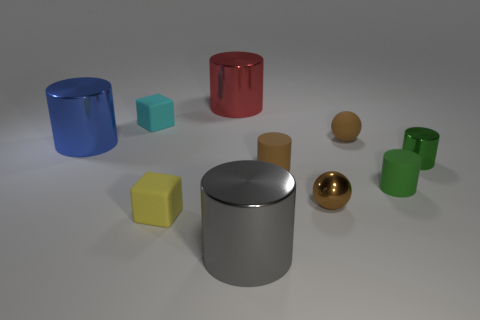Subtract all gray cylinders. How many cylinders are left? 5 Subtract 1 spheres. How many spheres are left? 1 Subtract all blocks. How many objects are left? 8 Subtract all gray cylinders. How many cylinders are left? 5 Subtract all purple cylinders. Subtract all gray spheres. How many cylinders are left? 6 Subtract all small green metal cylinders. Subtract all tiny rubber blocks. How many objects are left? 7 Add 6 shiny balls. How many shiny balls are left? 7 Add 6 balls. How many balls exist? 8 Subtract 0 yellow cylinders. How many objects are left? 10 Subtract all cyan spheres. How many brown blocks are left? 0 